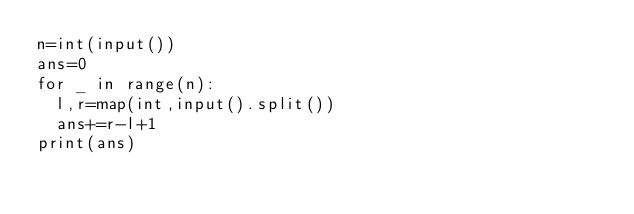<code> <loc_0><loc_0><loc_500><loc_500><_Python_>n=int(input())
ans=0
for _ in range(n):
  l,r=map(int,input().split())
  ans+=r-l+1
print(ans)</code> 